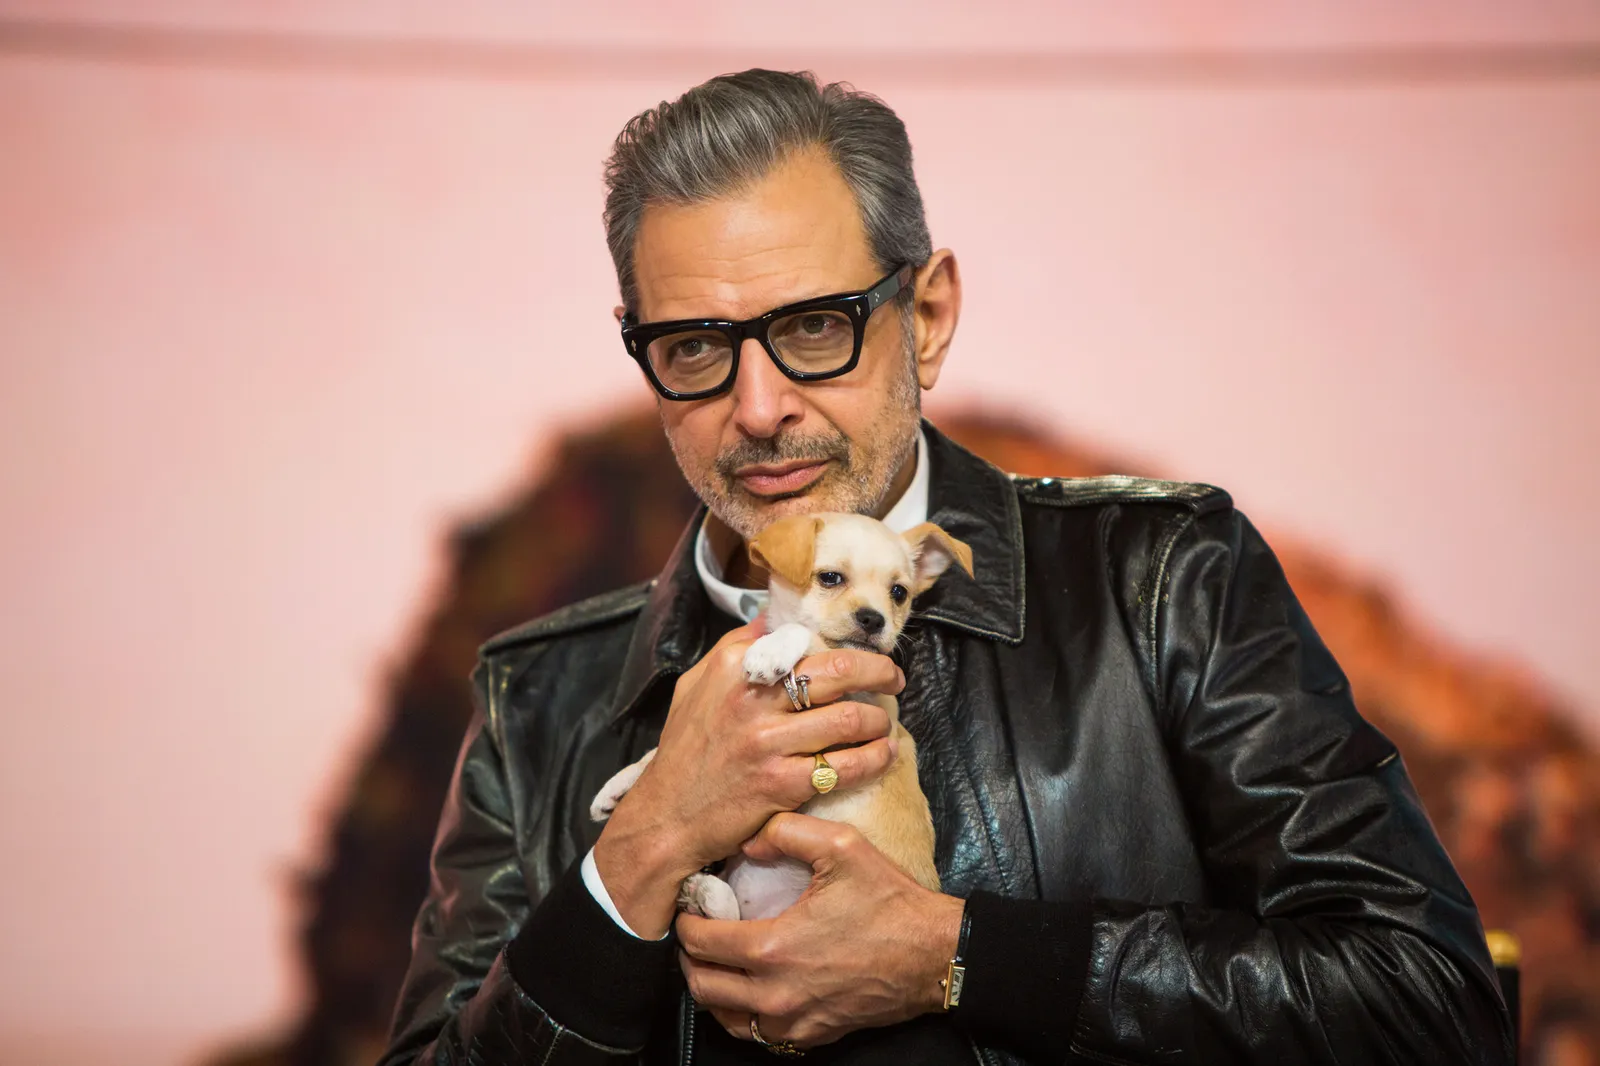Can you elaborate on the elements of the picture provided? In the image, a well-known actor is seen in a tender moment with a small, tan and white puppy. He is dressed in a stylish black leather jacket and wears glasses, adding to his charismatic appearance. His gentle smile and the way he cradles the puppy suggest a moment of quiet joy and tenderness. The backdrop features a vibrant pink color, which adds warmth to the image, contrasting with a rugged brown rock formation to his right. The overall composition exudes a feeling of warmth and charm, capturing a heartwarming interaction. 